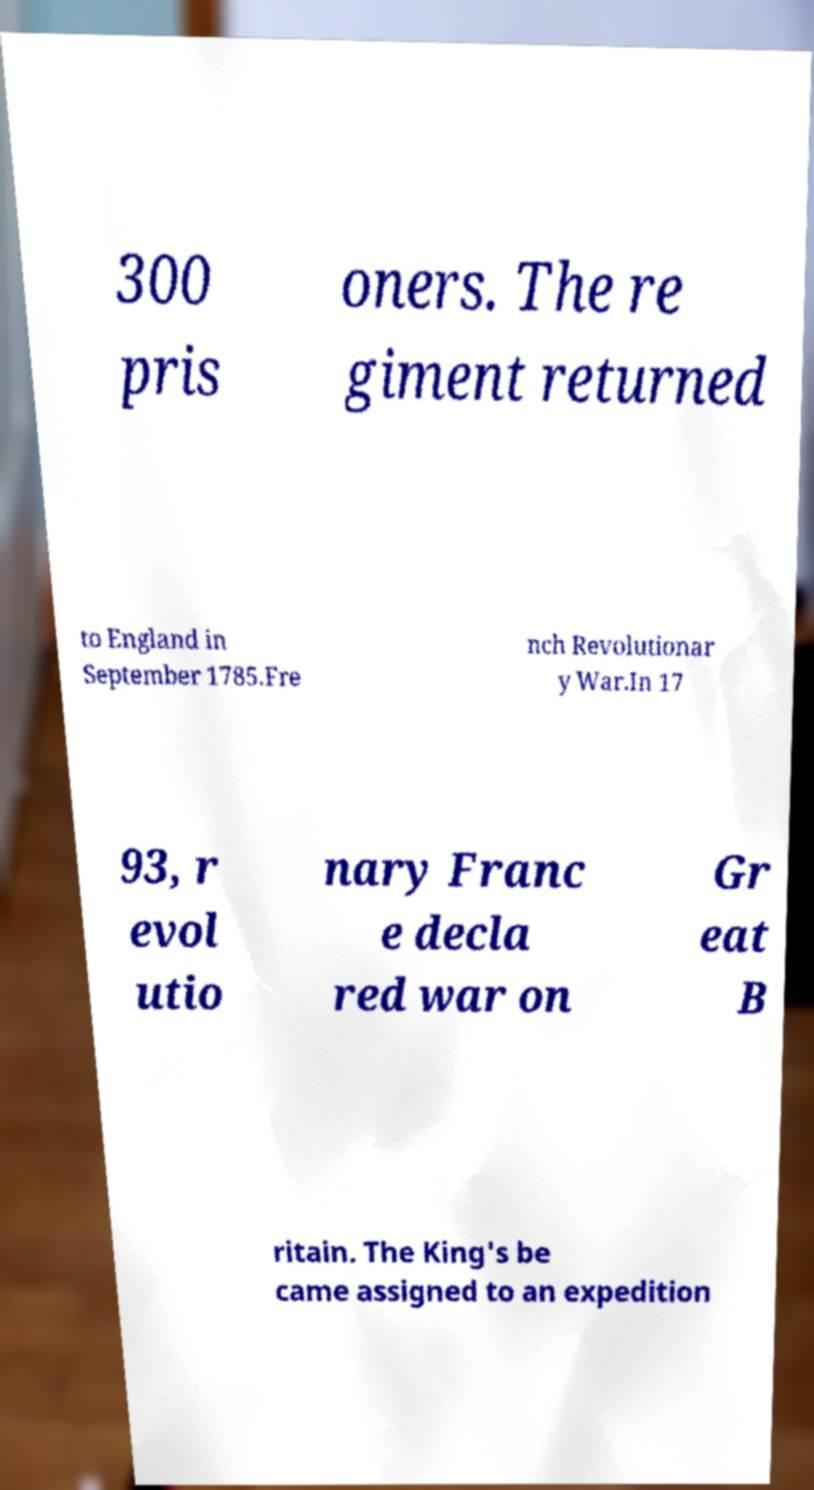Please identify and transcribe the text found in this image. 300 pris oners. The re giment returned to England in September 1785.Fre nch Revolutionar y War.In 17 93, r evol utio nary Franc e decla red war on Gr eat B ritain. The King's be came assigned to an expedition 